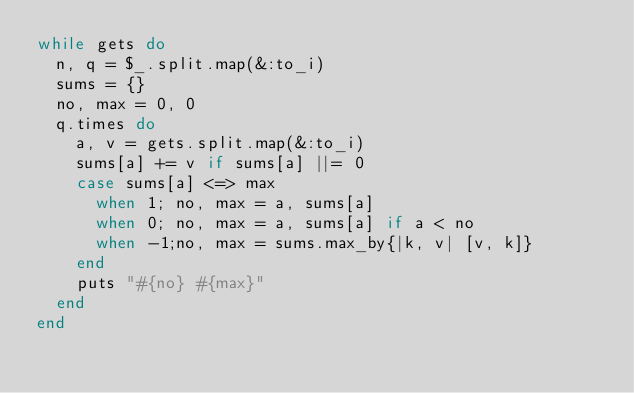<code> <loc_0><loc_0><loc_500><loc_500><_Ruby_>while gets do
  n, q = $_.split.map(&:to_i)
  sums = {}
  no, max = 0, 0
  q.times do
    a, v = gets.split.map(&:to_i)
    sums[a] += v if sums[a] ||= 0
    case sums[a] <=> max
      when 1; no, max = a, sums[a]
      when 0; no, max = a, sums[a] if a < no
      when -1;no, max = sums.max_by{|k, v| [v, k]}
    end
    puts "#{no} #{max}"
  end
end</code> 